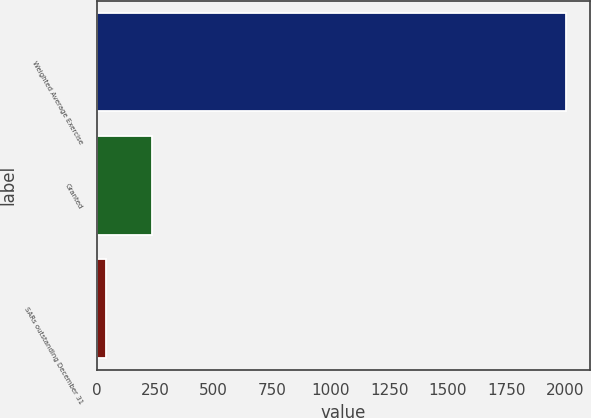<chart> <loc_0><loc_0><loc_500><loc_500><bar_chart><fcel>Weighted Average Exercise<fcel>Granted<fcel>SARs outstanding December 31<nl><fcel>2007<fcel>235.67<fcel>38.85<nl></chart> 